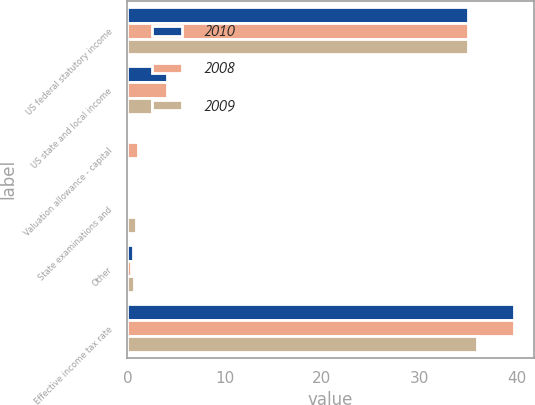Convert chart to OTSL. <chart><loc_0><loc_0><loc_500><loc_500><stacked_bar_chart><ecel><fcel>US federal statutory income<fcel>US state and local income<fcel>Valuation allowance - capital<fcel>State examinations and<fcel>Other<fcel>Effective income tax rate<nl><fcel>2010<fcel>35<fcel>4.1<fcel>0<fcel>0<fcel>0.6<fcel>39.7<nl><fcel>2008<fcel>35<fcel>4.1<fcel>1.1<fcel>0<fcel>0.4<fcel>39.8<nl><fcel>2009<fcel>35<fcel>2.5<fcel>0<fcel>0.9<fcel>0.7<fcel>35.9<nl></chart> 